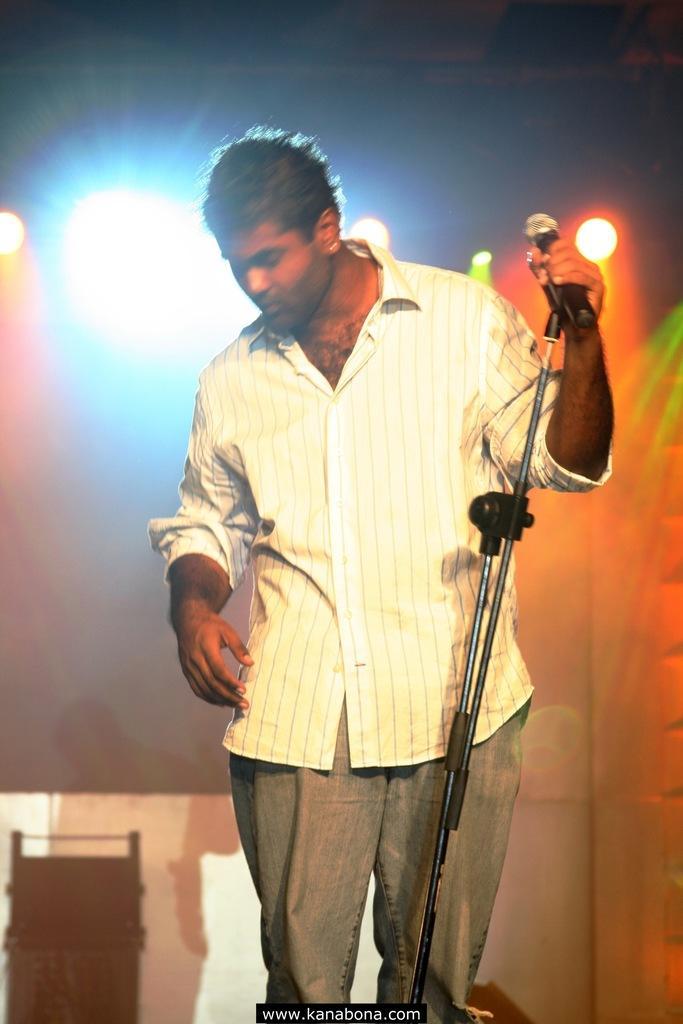Could you give a brief overview of what you see in this image? In the picture there is a man holding a mic and in the background there are several lights. 